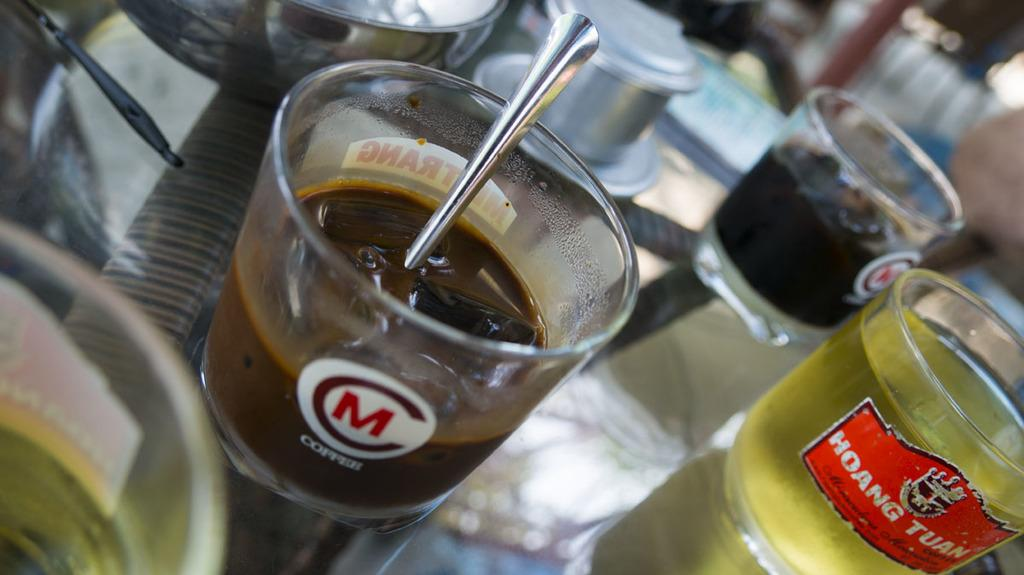<image>
Provide a brief description of the given image. Cups of liquid on a table including one cup that has the letter M on it. 